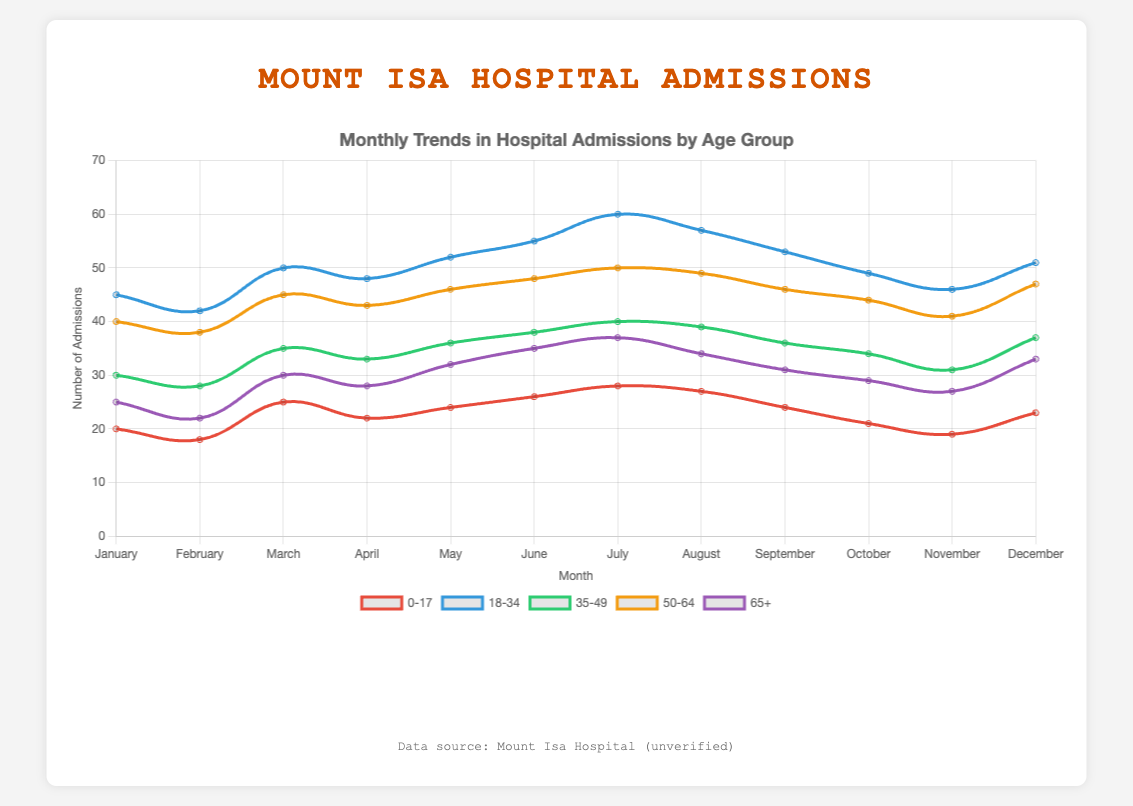What is the trend for the 0-17 age group's hospital admissions throughout the year? To find the trend, observe the plot for the 0-17 age group which is represented by the line with red color. From January to December, the monthly admissions slightly fluctuate, peaking in July and reaching the lowest point in February.
Answer: Slight fluctuation with a peak in July and lowest in February In which month does the 18-34 age group have the highest number of admissions? Look for the point with the highest value on the blue line which represents the 18-34 age group. The highest value occurs in July.
Answer: July Compare the hospital admissions for the 35-49 age group in March and November. Which month has higher admissions? Compare the value in March (35) on the green line against the value in November (31). March has higher admissions than November.
Answer: March What is the average number of admissions for the 50-64 age group in the first half of the year? Calculate the average of the values from January to June for the 50-64 age group (40, 38, 45, 43, 46, 48). The sum is 260, divided by 6 equals approximately 43.33.
Answer: 43.33 Which age group has the second-highest number of admissions in August? Identify the values for August across all groups: 0-17 (27), 18-34 (57), 35-49 (39), 50-64 (49), 65+ (34). The second highest value is 49, which belongs to the 50-64 age group.
Answer: 50-64 Calculate the total number of hospital admissions for the 65+ age group for the entire year. Sum up the monthly admissions from January to December for the 65+ age group (25 + 22 + 30 + 28 + 32 + 35 + 37 + 34 + 31 + 29 + 27 + 33), which equals 363.
Answer: 363 Which month shows the highest difference in admissions between the 0-17 and 18-34 age groups? Calculate the absolute difference for each month between the 0-17 and 18-34 age groups, then identify the month with the highest difference: 
(Jan: 25, Feb: 24, Mar: 25, Apr: 26, May: 28, Jun: 29, Jul: 32, Aug: 30, Sep: 29, Oct: 28, Nov: 27, Dec: 28). July has the highest difference of 32.
Answer: July Is there a significant decrease in admissions for the 50-64 age group moving from July to August? Compare the values in July (50) and August (49) for the 50-64 age group. The decrease is 1, which is not significant.
Answer: No Which age group has the most stable number of hospital admissions throughout the year? Look for the group with the least fluctuation in values. The 35-49 age group's values range from 28 to 40, suggesting stability compared to others.
Answer: 35-49 What's the median number of admissions for the 18-34 age group over the year? Sort the monthly values (42, 45, 46, 48, 49, 50, 51, 52, 53, 55, 57, 60). The median is the average of the 6th and 7th values: (50 + 51) / 2 = 50.5.
Answer: 50.5 